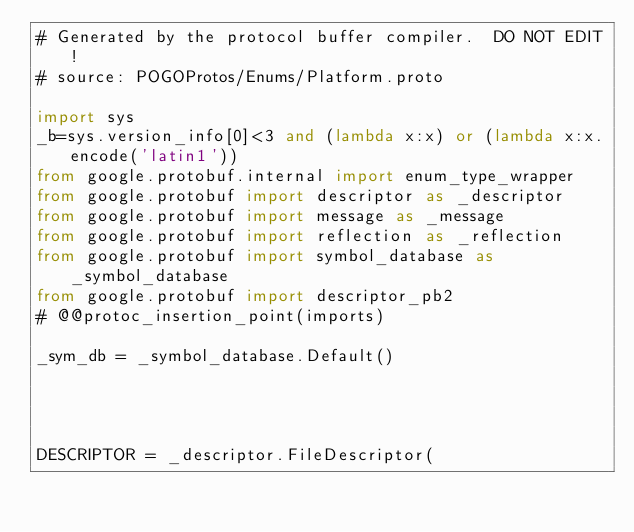Convert code to text. <code><loc_0><loc_0><loc_500><loc_500><_Python_># Generated by the protocol buffer compiler.  DO NOT EDIT!
# source: POGOProtos/Enums/Platform.proto

import sys
_b=sys.version_info[0]<3 and (lambda x:x) or (lambda x:x.encode('latin1'))
from google.protobuf.internal import enum_type_wrapper
from google.protobuf import descriptor as _descriptor
from google.protobuf import message as _message
from google.protobuf import reflection as _reflection
from google.protobuf import symbol_database as _symbol_database
from google.protobuf import descriptor_pb2
# @@protoc_insertion_point(imports)

_sym_db = _symbol_database.Default()




DESCRIPTOR = _descriptor.FileDescriptor(</code> 